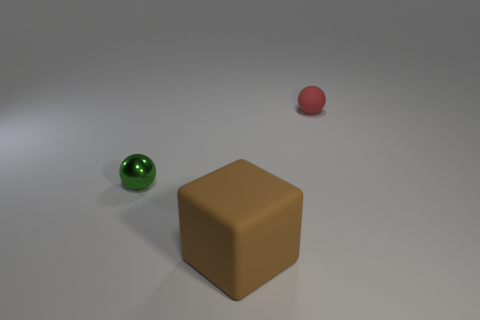Do the rubber ball that is behind the brown thing and the matte cube have the same color? no 